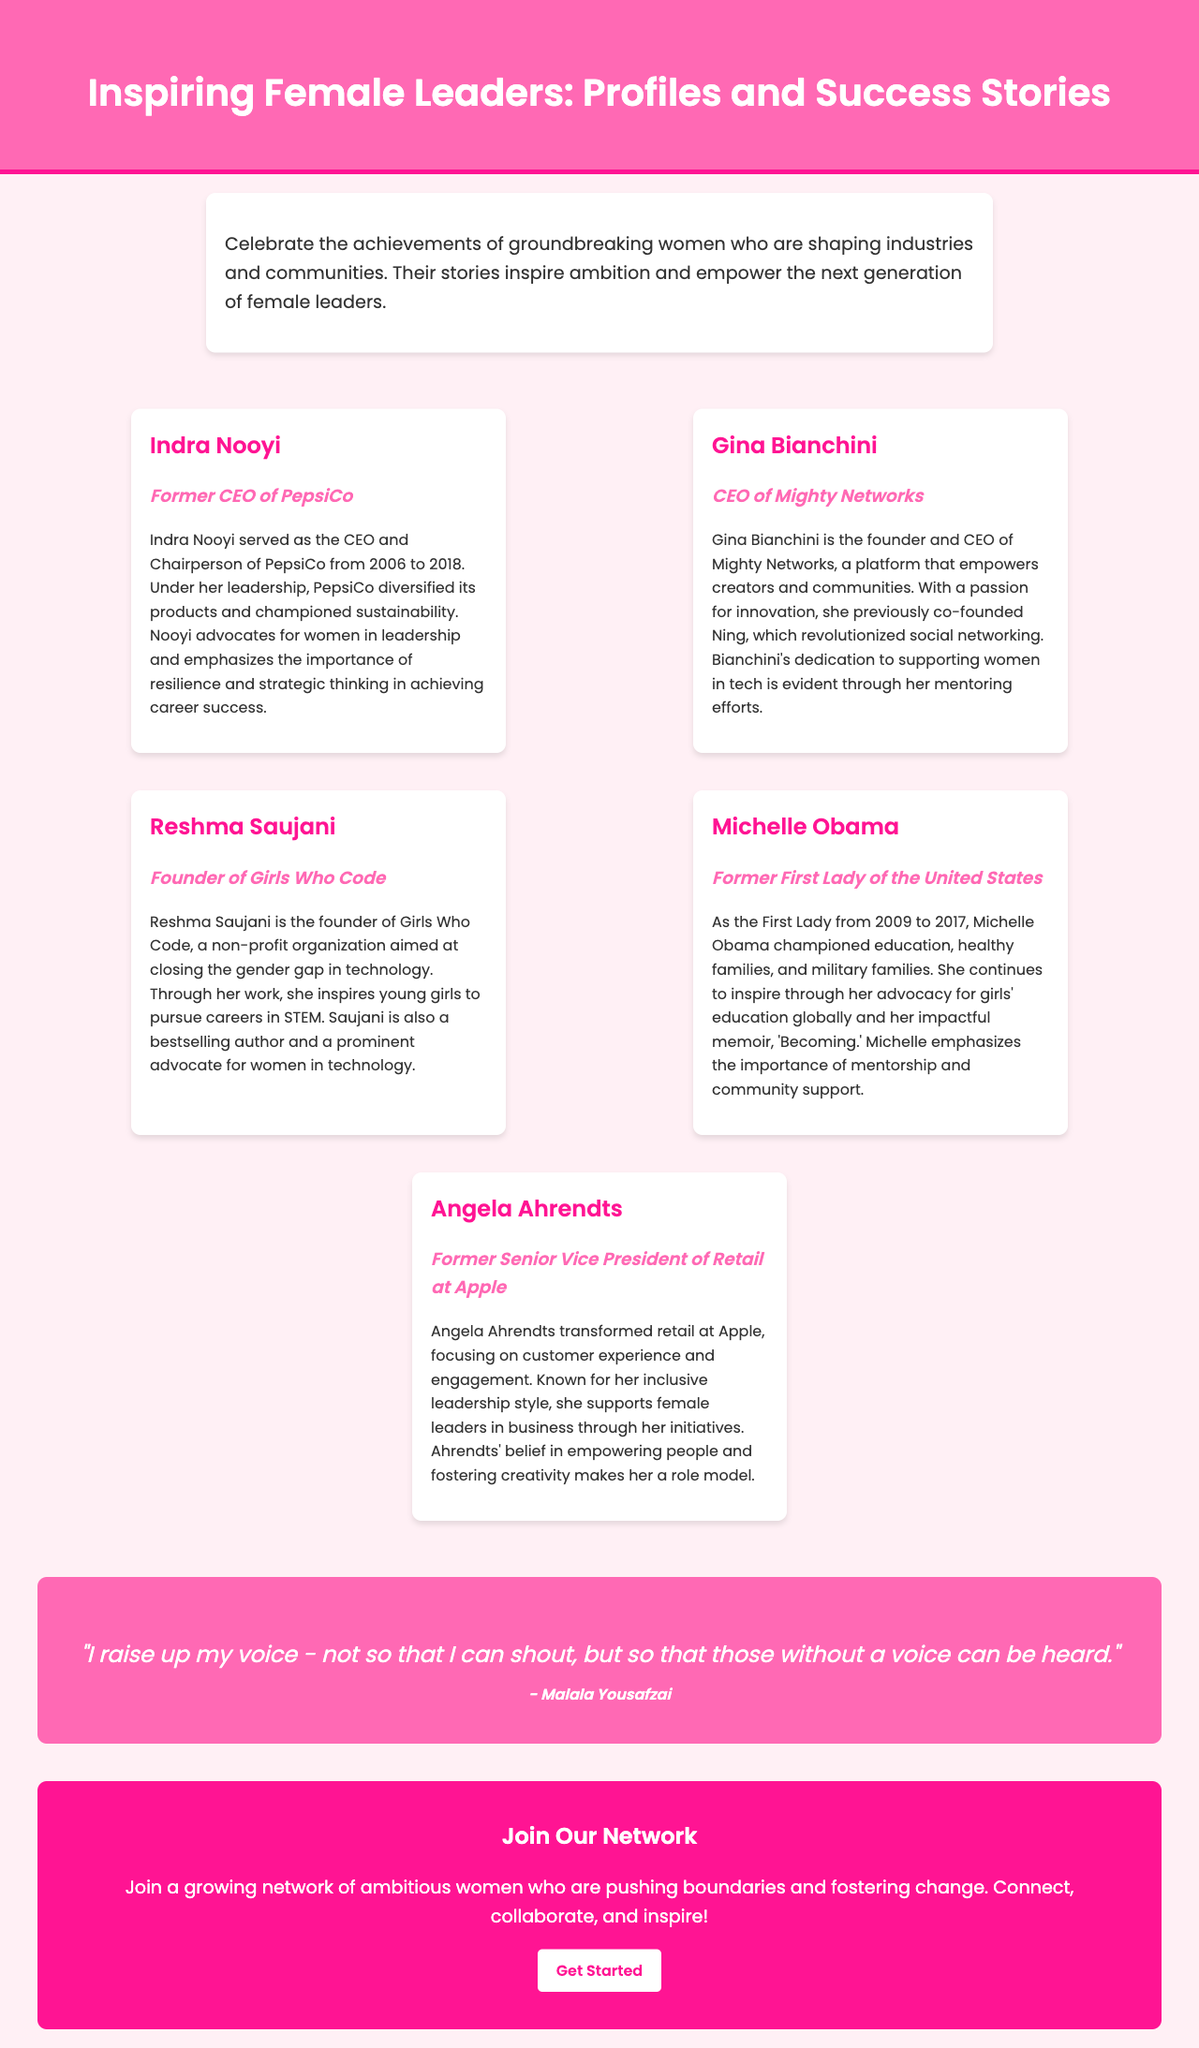What is the title of the brochure? The title of the brochure is found in the header section, which prominently displays the name of the document.
Answer: Inspiring Female Leaders: Profiles and Success Stories Who is the former CEO of PepsiCo? This information is provided in the profile section that highlights notable female leaders.
Answer: Indra Nooyi What organization did Reshma Saujani found? The profile about Reshma Saujani specifically mentions the organization she created for girls in technology.
Answer: Girls Who Code What is the main theme of the brochure? The theme is described in the introductory paragraph and focuses on celebrating female achievements and inspiring the next generation.
Answer: Celebrate the achievements of groundbreaking women How long did Michelle Obama serve as First Lady? The profile of Michelle Obama states the time frame of her service in that role.
Answer: 2009 to 2017 Which color is used for the quote background? The background color of the quote is specifically mentioned in the styling of the document.
Answer: #FF69B4 What is Gina Bianchini's role at Mighty Networks? The profile of Gina Bianchini describes her position in the organization she leads.
Answer: CEO What is the call to action in the brochure? The call to action is presented in the last section encouraging engagement with the network.
Answer: Join Our Network 